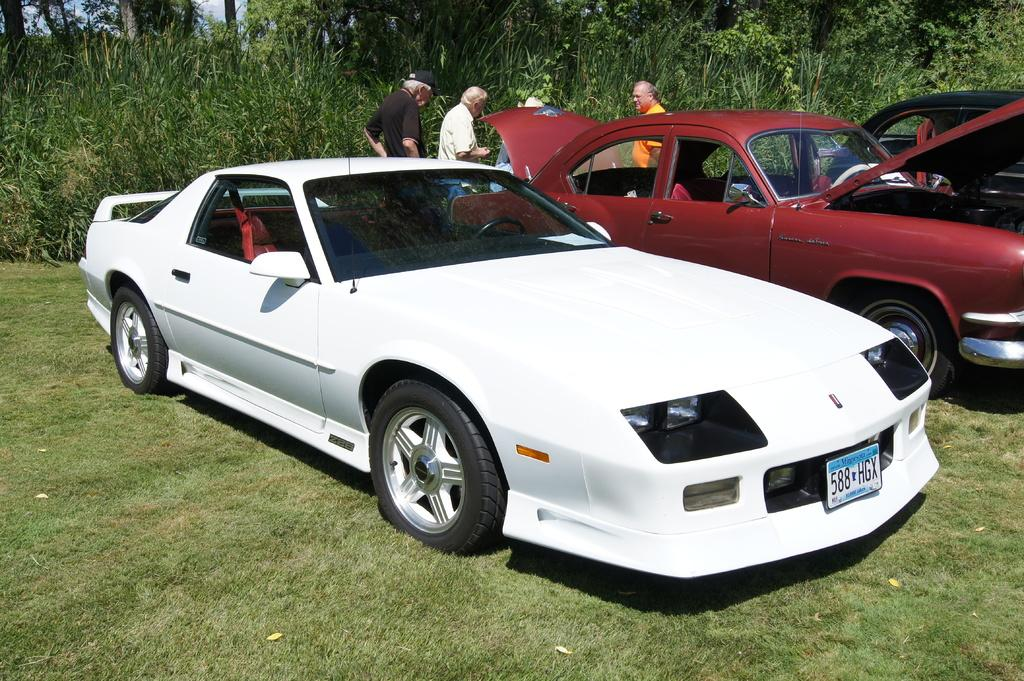What can be seen in the image related to vehicles? There are cars parked in the image. Can you describe the condition of one of the cars? One car has its trunk and bonnet open. What else is present in the image besides the cars? There are people standing in the image, as well as plants, trees, and grass on the ground. Where are the children playing in the image? There is no mention of children in the image, so we cannot determine where they might be playing. 